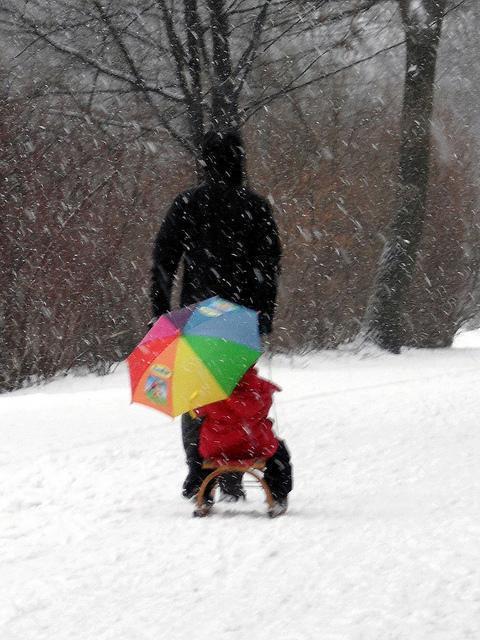In which location might this umbrella be appropriate?
Select the accurate answer and provide justification: `Answer: choice
Rationale: srationale.`
Options: Veterans parade, klan rally, volcano, pride parade. Answer: pride parade.
Rationale: The colors that represent this sect of america are rainbow colored. 